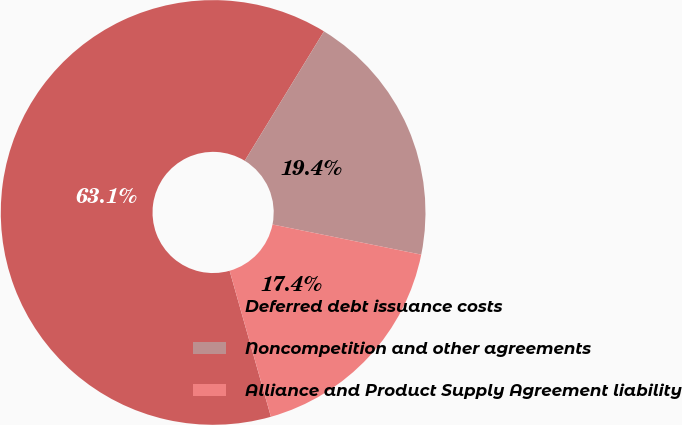Convert chart to OTSL. <chart><loc_0><loc_0><loc_500><loc_500><pie_chart><fcel>Deferred debt issuance costs<fcel>Noncompetition and other agreements<fcel>Alliance and Product Supply Agreement liability<nl><fcel>63.13%<fcel>19.44%<fcel>17.43%<nl></chart> 